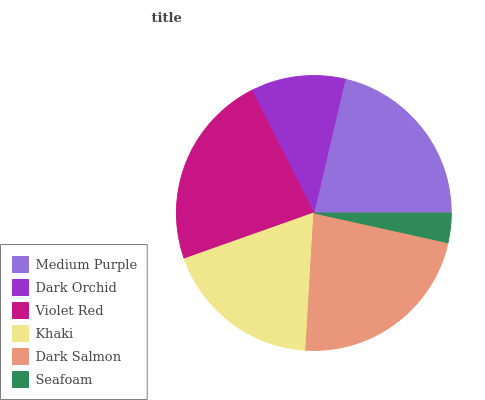Is Seafoam the minimum?
Answer yes or no. Yes. Is Violet Red the maximum?
Answer yes or no. Yes. Is Dark Orchid the minimum?
Answer yes or no. No. Is Dark Orchid the maximum?
Answer yes or no. No. Is Medium Purple greater than Dark Orchid?
Answer yes or no. Yes. Is Dark Orchid less than Medium Purple?
Answer yes or no. Yes. Is Dark Orchid greater than Medium Purple?
Answer yes or no. No. Is Medium Purple less than Dark Orchid?
Answer yes or no. No. Is Medium Purple the high median?
Answer yes or no. Yes. Is Khaki the low median?
Answer yes or no. Yes. Is Khaki the high median?
Answer yes or no. No. Is Dark Orchid the low median?
Answer yes or no. No. 